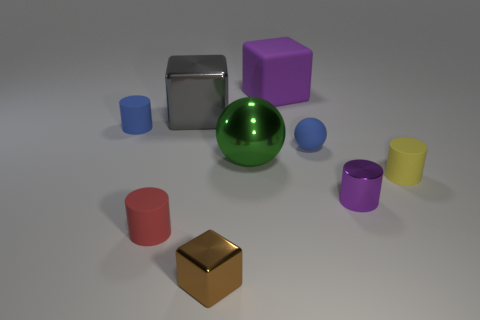Subtract all large blocks. How many blocks are left? 1 Subtract all blue cylinders. How many cylinders are left? 3 Subtract 2 spheres. How many spheres are left? 0 Add 1 gray objects. How many objects exist? 10 Subtract all green cylinders. How many red blocks are left? 0 Subtract all small red rubber spheres. Subtract all yellow cylinders. How many objects are left? 8 Add 2 metal cylinders. How many metal cylinders are left? 3 Add 8 gray metal things. How many gray metal things exist? 9 Subtract 1 red cylinders. How many objects are left? 8 Subtract all cubes. How many objects are left? 6 